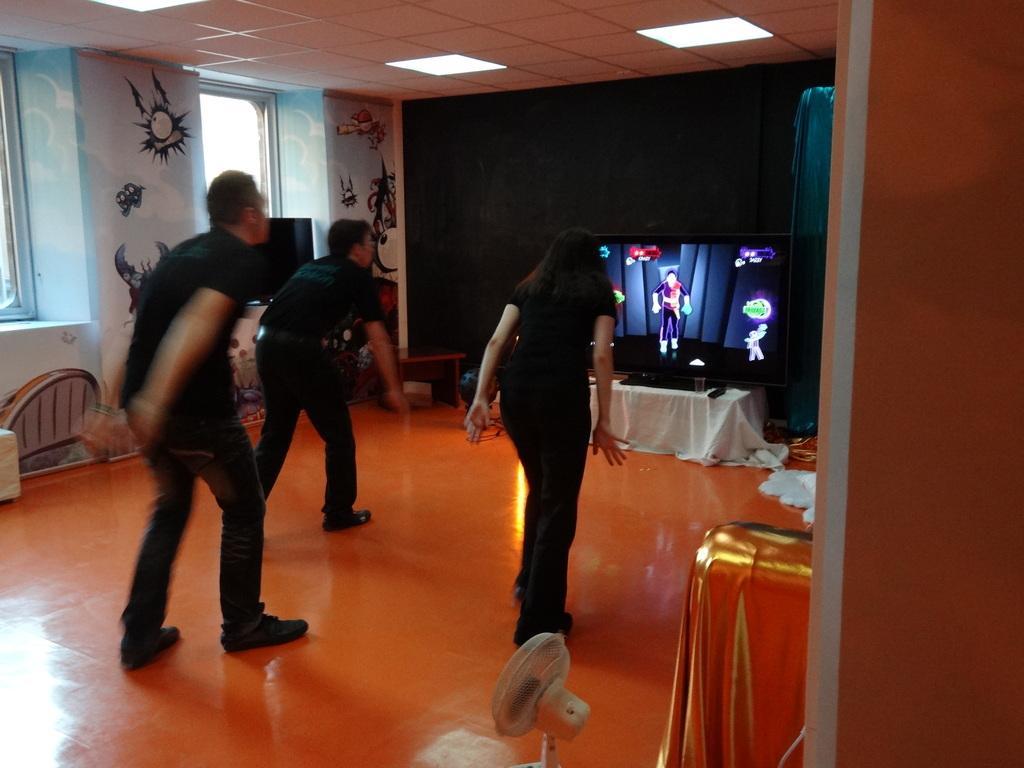How would you summarize this image in a sentence or two? In this image, there are three persons standing on the floor. I can see a painting on the wall and there are windows. In front of the people, I can see a television on a table and there are few other objects. At the bottom of the image, I can see a portable fan and an object. At the top of the image, there are ceiling lights. 